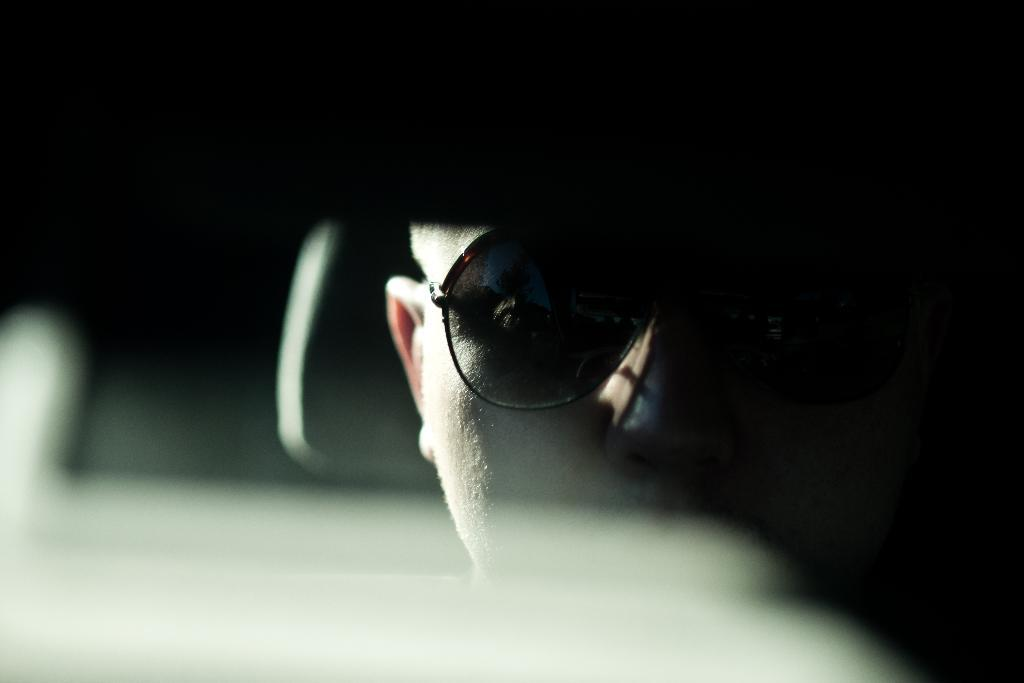What is the main subject of the image? There is a person's face in the image. What is the person wearing in the image? The person is wearing black-colored goggles. What color is the background of the image? The background of the image is black. How comfortable is the person's chair in the image? There is no chair visible in the image, so it is impossible to determine the comfort level. 